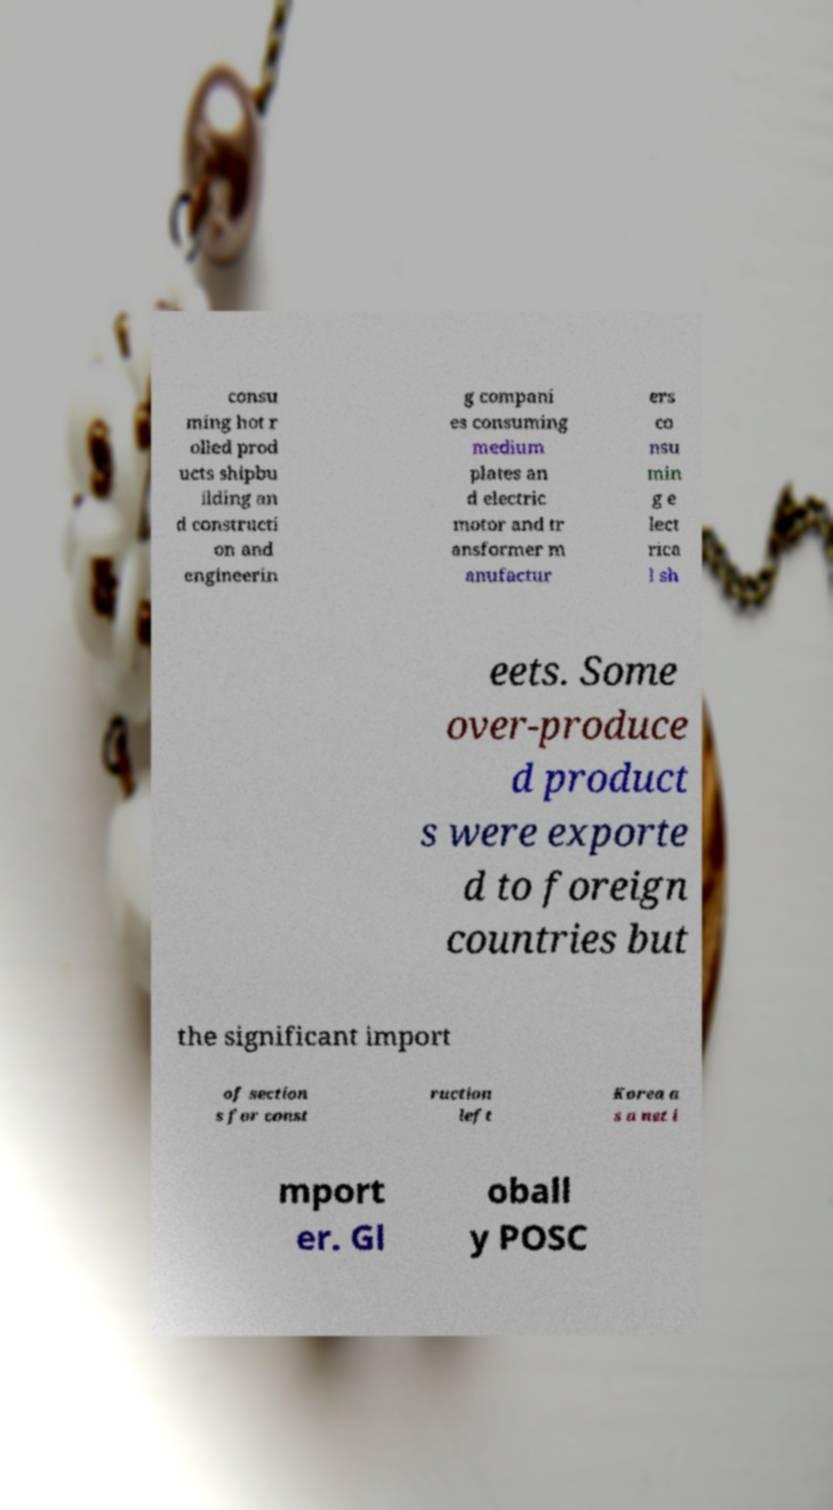Could you assist in decoding the text presented in this image and type it out clearly? consu ming hot r olled prod ucts shipbu ilding an d constructi on and engineerin g compani es consuming medium plates an d electric motor and tr ansformer m anufactur ers co nsu min g e lect rica l sh eets. Some over-produce d product s were exporte d to foreign countries but the significant import of section s for const ruction left Korea a s a net i mport er. Gl oball y POSC 